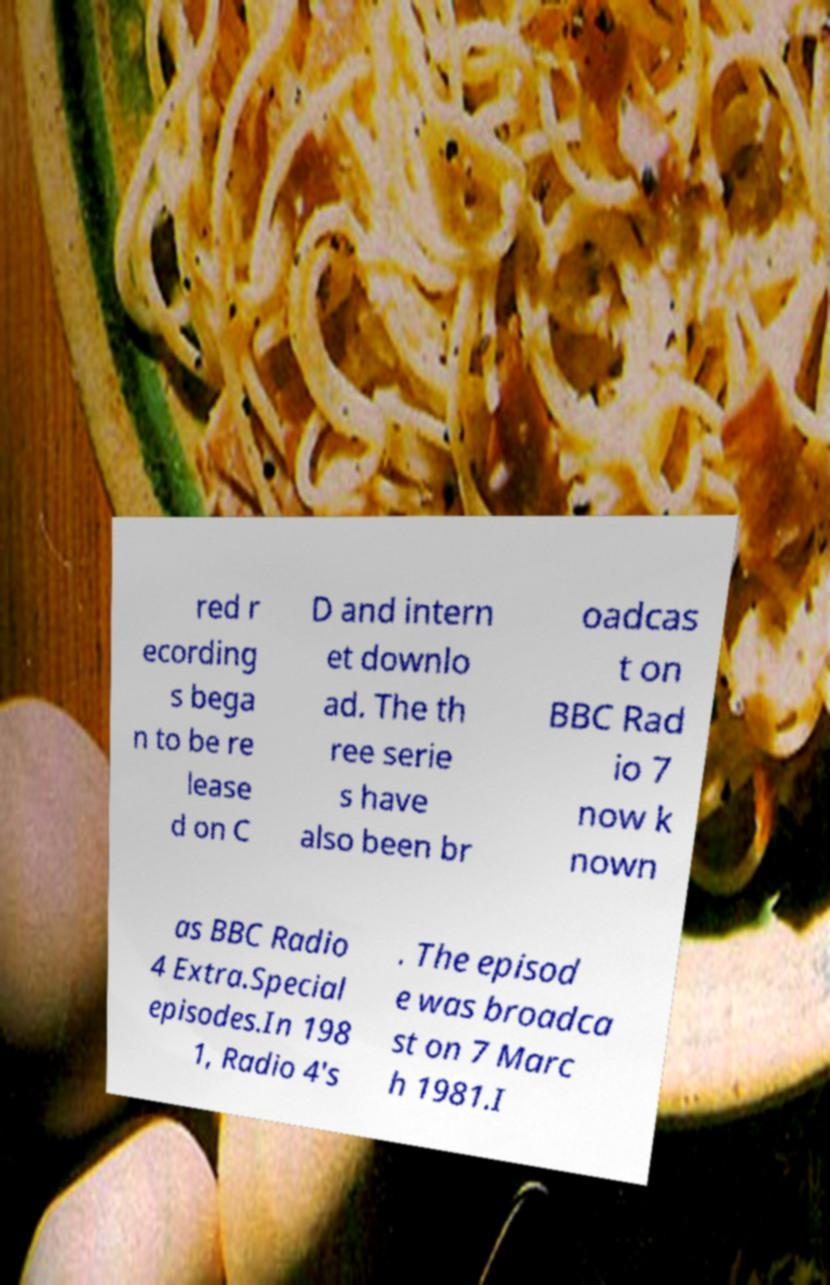Could you assist in decoding the text presented in this image and type it out clearly? red r ecording s bega n to be re lease d on C D and intern et downlo ad. The th ree serie s have also been br oadcas t on BBC Rad io 7 now k nown as BBC Radio 4 Extra.Special episodes.In 198 1, Radio 4's . The episod e was broadca st on 7 Marc h 1981.I 